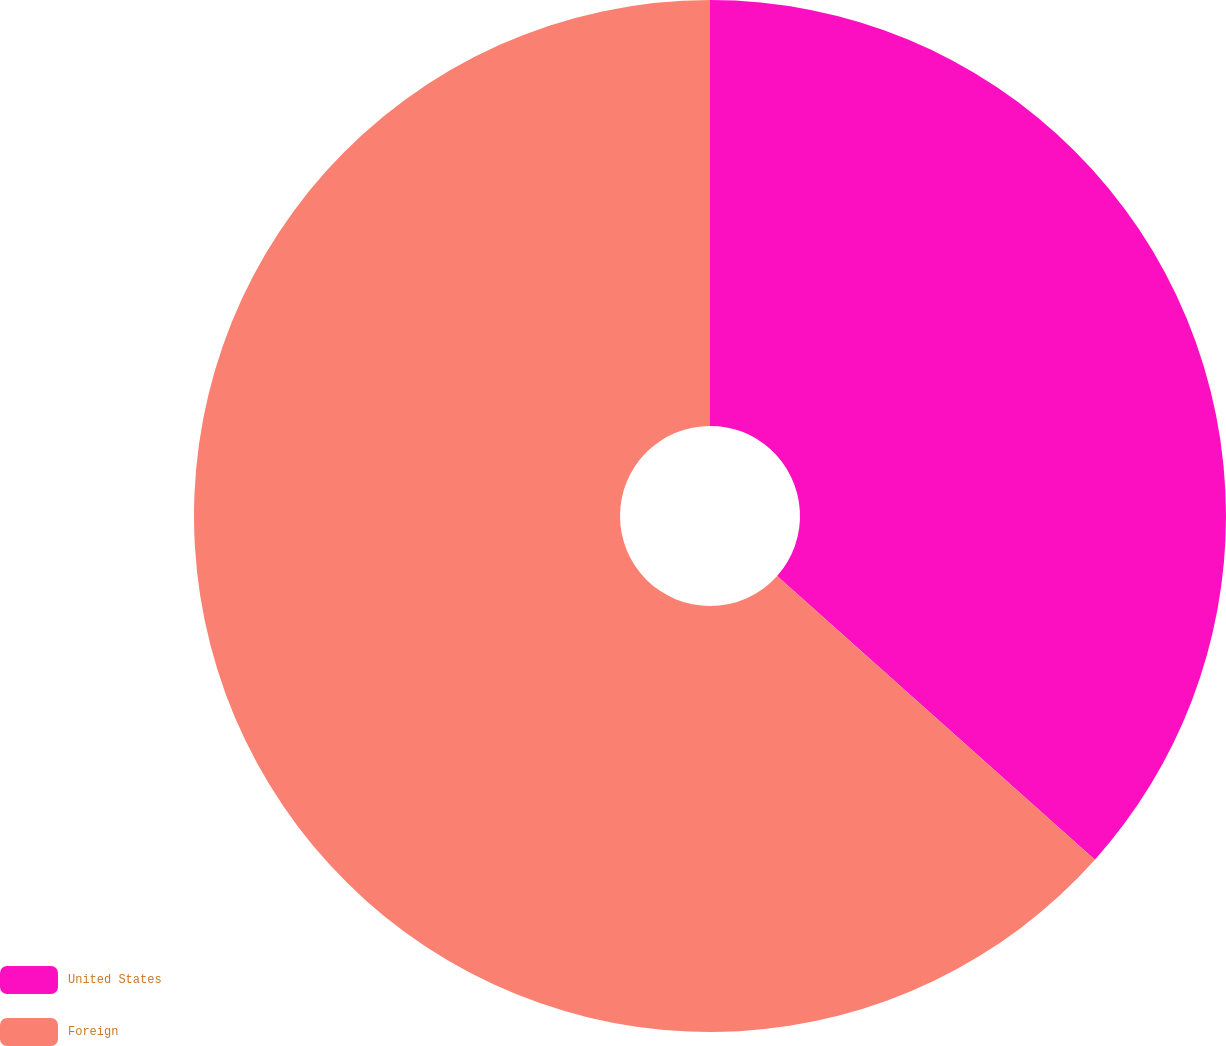Convert chart to OTSL. <chart><loc_0><loc_0><loc_500><loc_500><pie_chart><fcel>United States<fcel>Foreign<nl><fcel>36.6%<fcel>63.4%<nl></chart> 